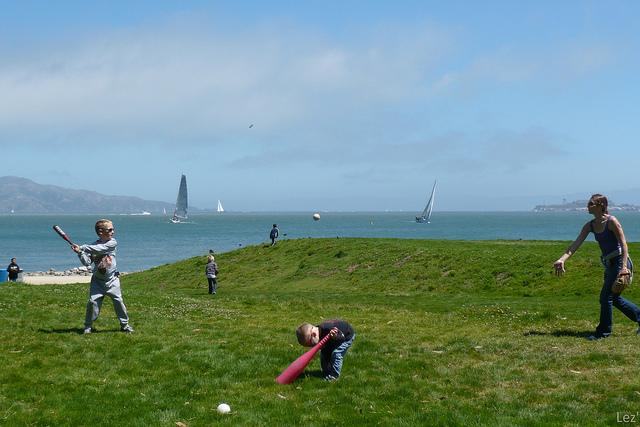What sport are they playing?
Short answer required. Baseball. Does it appear breezy or still?
Answer briefly. Breezy. Is the man being normal?
Give a very brief answer. Yes. What is the child holding?
Concise answer only. Bat. What sport are these people playing?
Give a very brief answer. Baseball. Do both of the kids have kites?
Short answer required. No. Are there clouds in the sky?
Be succinct. Yes. Where are the men?
Be succinct. Beach. Are there kites in the sky?
Concise answer only. No. What is in the background?
Be succinct. Ocean. What are they doing?
Quick response, please. Playing baseball. What is the kid holding?
Give a very brief answer. Bat. Are they on a beach?
Write a very short answer. No. What are the people playing?
Keep it brief. Baseball. What kind of game are they playing?
Be succinct. Baseball. Is the girl trying to fly a kite?
Be succinct. No. Has the grass been cut?
Answer briefly. Yes. 